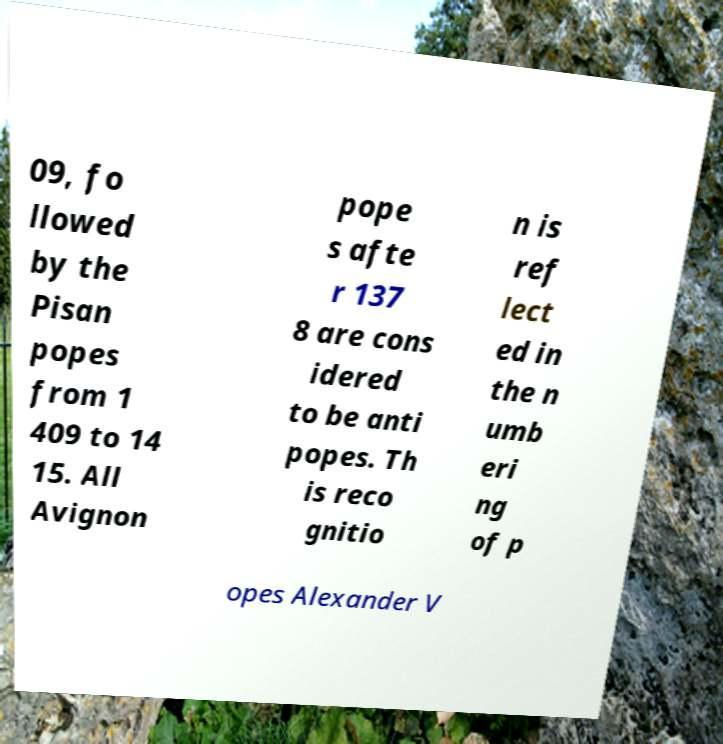For documentation purposes, I need the text within this image transcribed. Could you provide that? 09, fo llowed by the Pisan popes from 1 409 to 14 15. All Avignon pope s afte r 137 8 are cons idered to be anti popes. Th is reco gnitio n is ref lect ed in the n umb eri ng of p opes Alexander V 